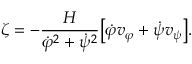<formula> <loc_0><loc_0><loc_500><loc_500>\zeta = - \frac { H } { \dot { \varphi } ^ { 2 } + \dot { \psi } ^ { 2 } } \left [ \dot { \varphi } v _ { \varphi } + \dot { \psi } v _ { \psi } \right ] .</formula> 